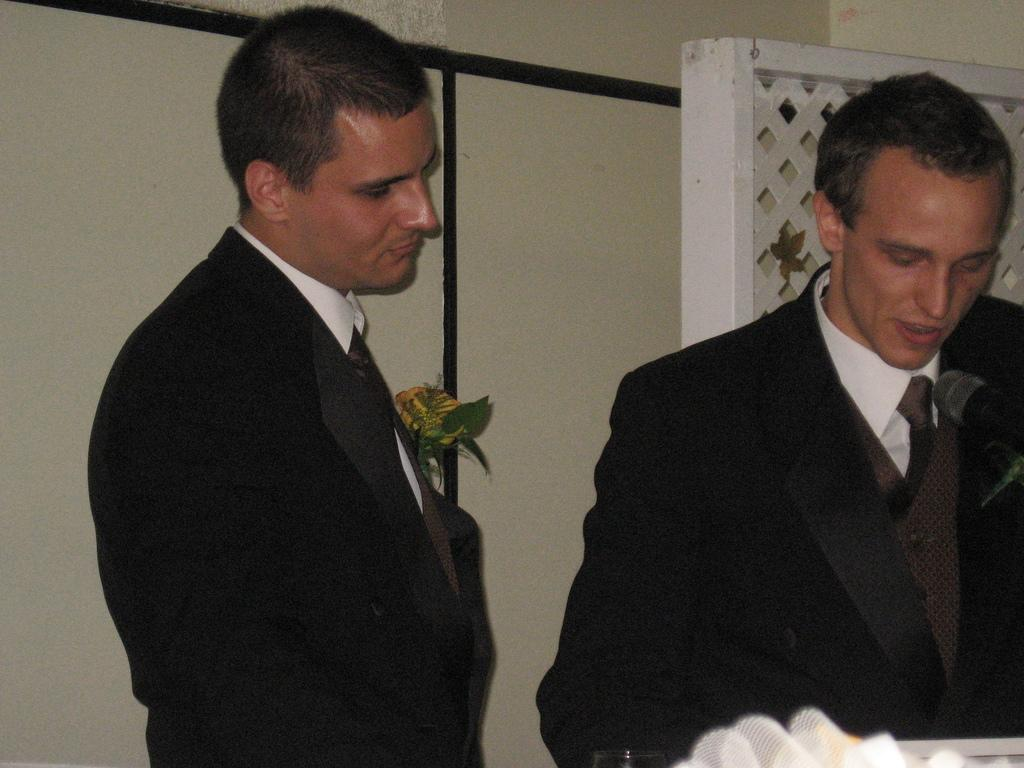How many people are in the image? There are two men in the image. What are the men wearing? The men are wearing black suits. What can be seen in the background of the image? There is a plant visible in the background of the image. What type of kite is the stranger flying in the image? There is no stranger or kite present in the image; it features two men wearing black suits. Can you hear the voice of the person taking the picture in the image? The image is a still photograph, so there is no sound or voice present. 